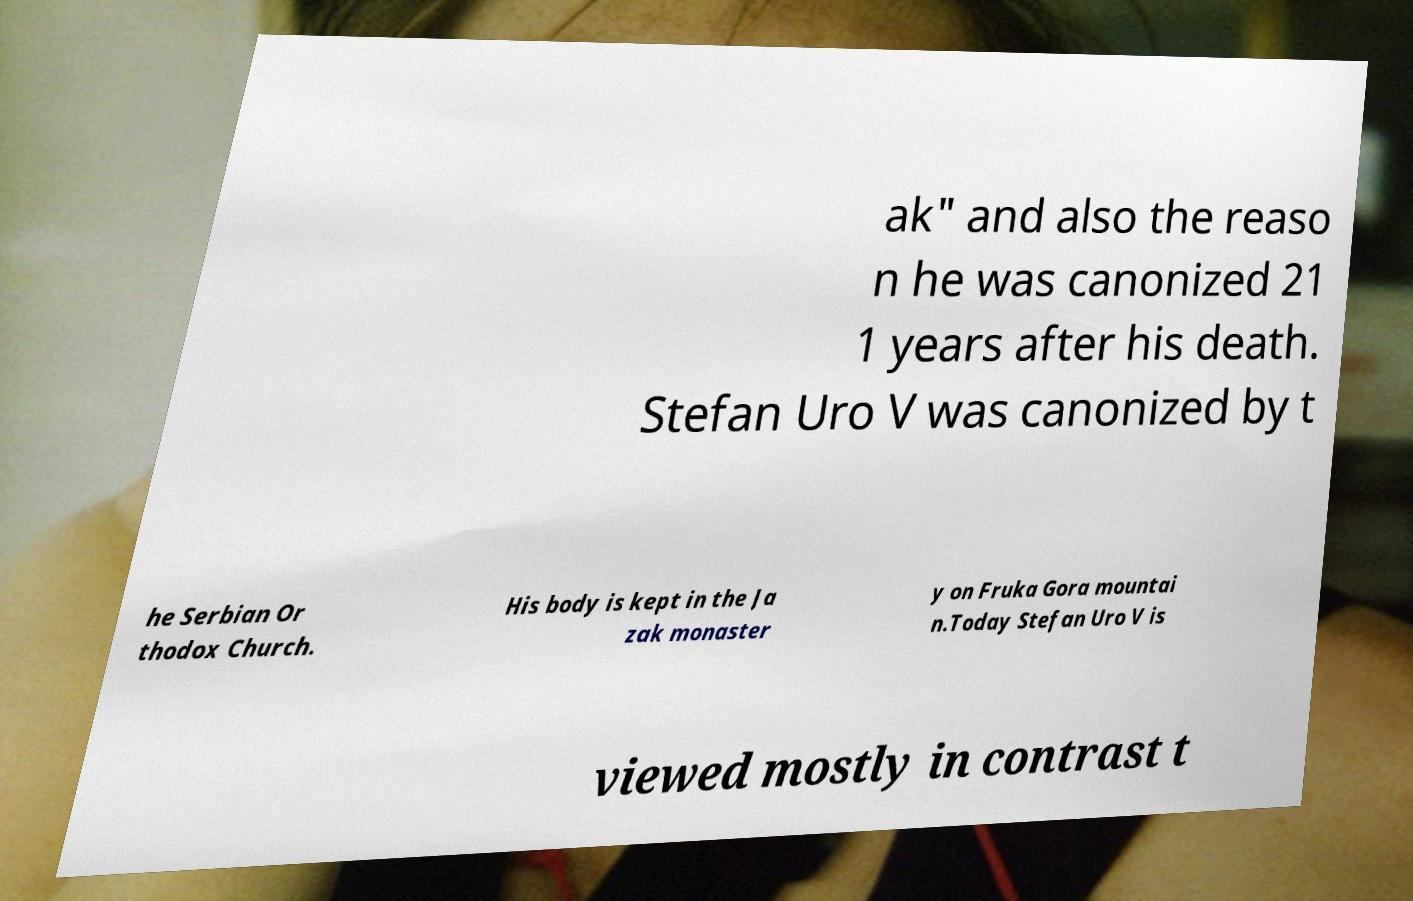I need the written content from this picture converted into text. Can you do that? ak" and also the reaso n he was canonized 21 1 years after his death. Stefan Uro V was canonized by t he Serbian Or thodox Church. His body is kept in the Ja zak monaster y on Fruka Gora mountai n.Today Stefan Uro V is viewed mostly in contrast t 